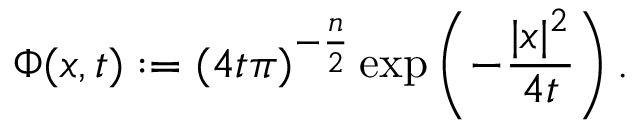Convert formula to latex. <formula><loc_0><loc_0><loc_500><loc_500>\Phi ( x , t ) \colon = ( 4 t \pi ) ^ { - { \frac { n } { 2 } } } \exp \left ( - { \frac { | x | ^ { 2 } } { 4 t } } \right ) .</formula> 